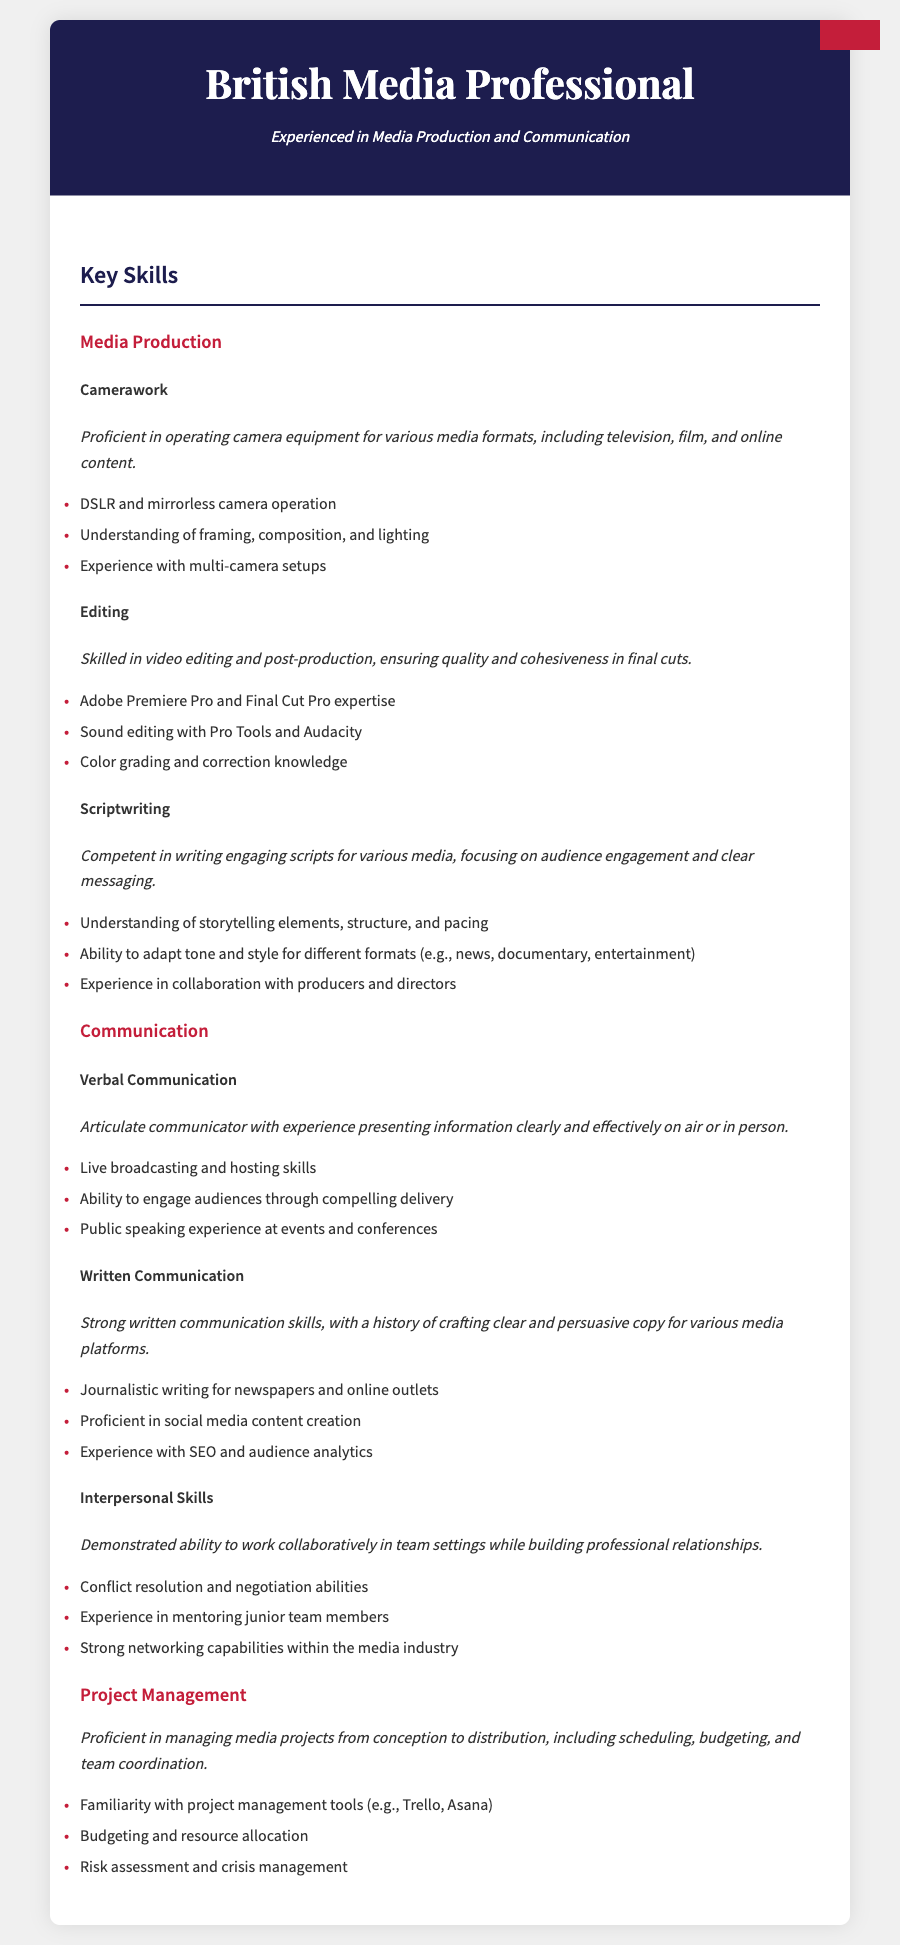What is the primary focus of the resume? The resume is specifically tailored for a media professional with experience in media production and communication.
Answer: Media Production and Communication What software is mentioned for video editing? The resume lists Adobe Premiere Pro and Final Cut Pro as key software for video editing.
Answer: Adobe Premiere Pro and Final Cut Pro What type of skills does the candidate possess in the context of scriptwriting? The skills in scriptwriting include understanding storytelling elements, adaptation of tone, and collaboration with producers.
Answer: Storytelling elements, adaptation of tone, collaboration How many main sections are in the document? The resume contains three main sections: Media Production, Communication, and Project Management.
Answer: Three What type of camera operation is highlighted in the skills? The candidate highlights proficiency in operating DSLR and mirrorless camera equipment.
Answer: DSLR and mirrorless camera operation Which communication skill involves public speaking? The verbal communication skill section specifically mentions experience in public speaking at events and conferences.
Answer: Verbal Communication What capability related to project management is emphasized? The resume emphasizes budgeting and resource allocation as a key capability in project management.
Answer: Budgeting and resource allocation How does the candidate engage with audiences? The candidate engages audiences through compelling delivery in their verbal communication skills.
Answer: Compelling delivery What describes the candidate's interpersonal skills? The interpersonal skills are characterized by the ability to work collaboratively and build professional relationships.
Answer: Collaborative and relationship-building Which editing software is used for sound editing? The resume mentions Pro Tools and Audacity as sound editing software.
Answer: Pro Tools and Audacity 